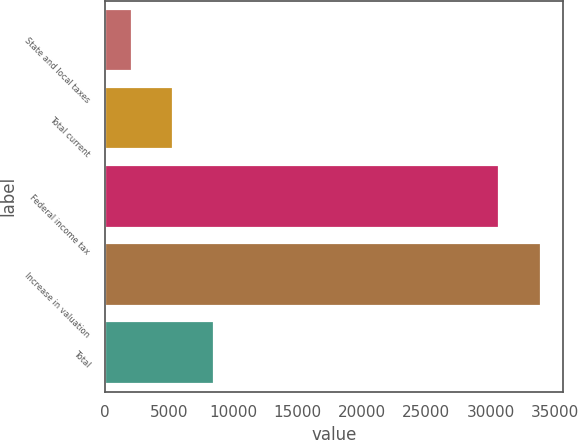<chart> <loc_0><loc_0><loc_500><loc_500><bar_chart><fcel>State and local taxes<fcel>Total current<fcel>Federal income tax<fcel>Increase in valuation<fcel>Total<nl><fcel>2104<fcel>5288.1<fcel>30686<fcel>33945<fcel>8472.2<nl></chart> 